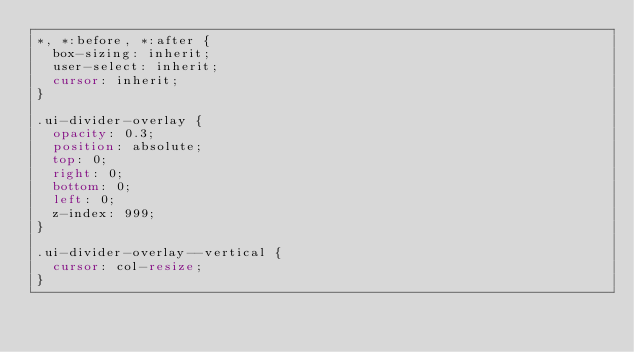Convert code to text. <code><loc_0><loc_0><loc_500><loc_500><_CSS_>*, *:before, *:after {
  box-sizing: inherit;
  user-select: inherit;
  cursor: inherit;
}

.ui-divider-overlay {
  opacity: 0.3;
  position: absolute;
  top: 0;
  right: 0;
  bottom: 0;
  left: 0;
  z-index: 999;
}

.ui-divider-overlay--vertical {
  cursor: col-resize;
}
</code> 